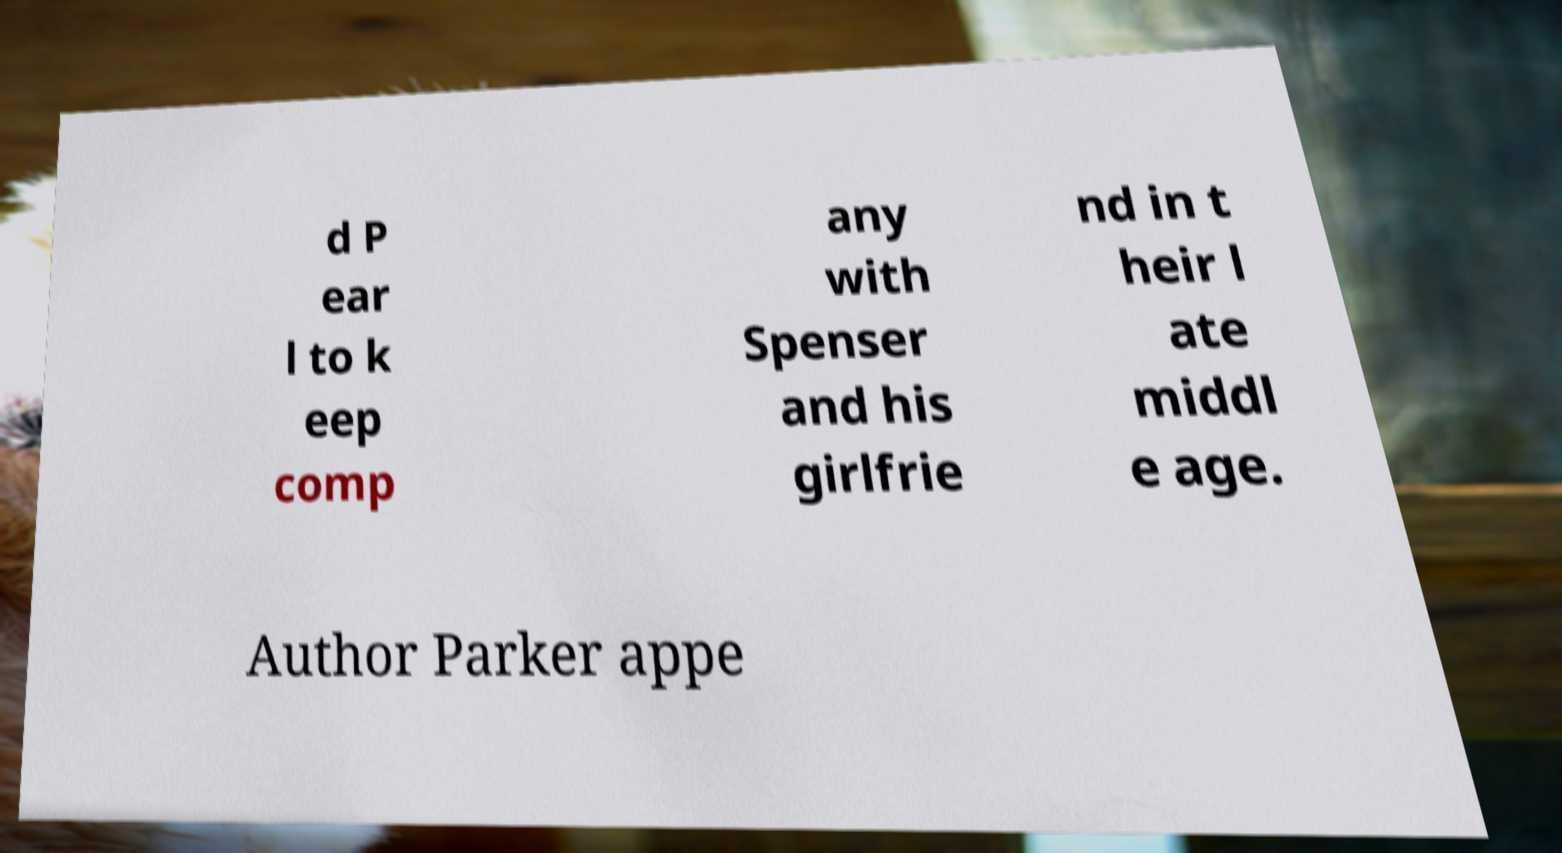I need the written content from this picture converted into text. Can you do that? d P ear l to k eep comp any with Spenser and his girlfrie nd in t heir l ate middl e age. Author Parker appe 